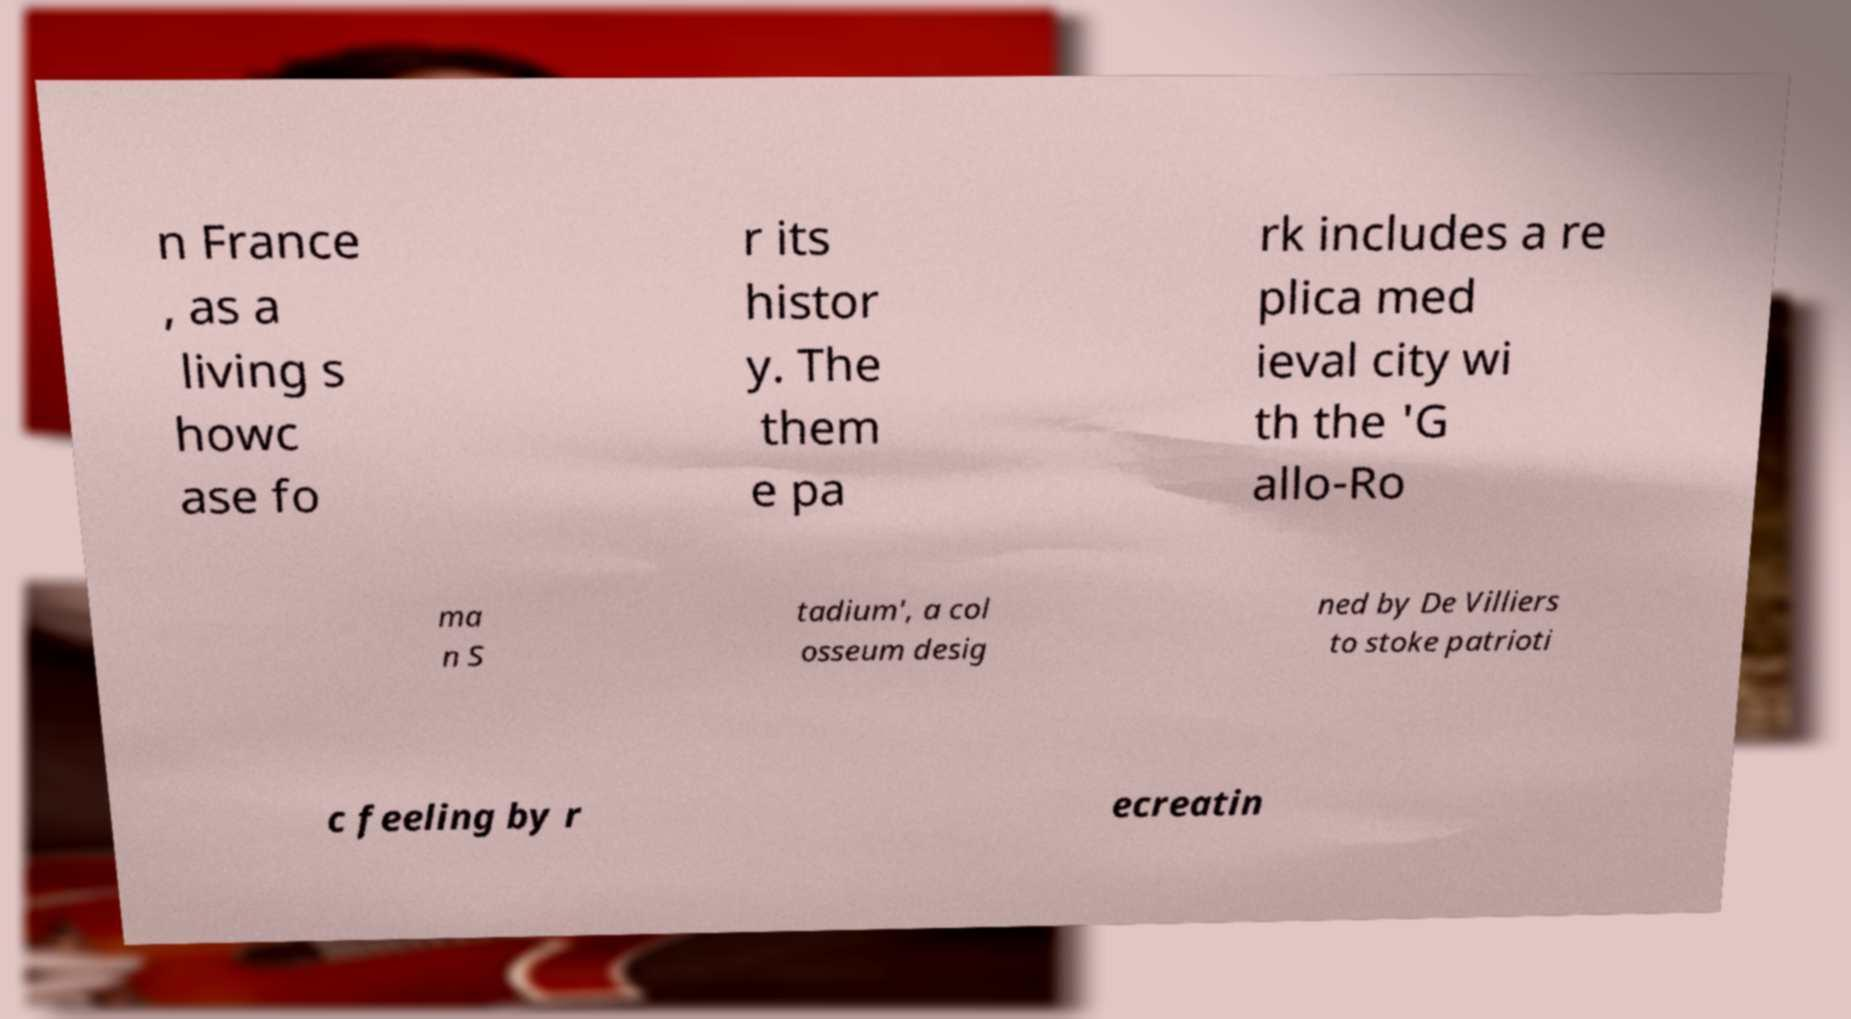Could you assist in decoding the text presented in this image and type it out clearly? n France , as a living s howc ase fo r its histor y. The them e pa rk includes a re plica med ieval city wi th the 'G allo-Ro ma n S tadium', a col osseum desig ned by De Villiers to stoke patrioti c feeling by r ecreatin 